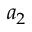Convert formula to latex. <formula><loc_0><loc_0><loc_500><loc_500>a _ { 2 }</formula> 